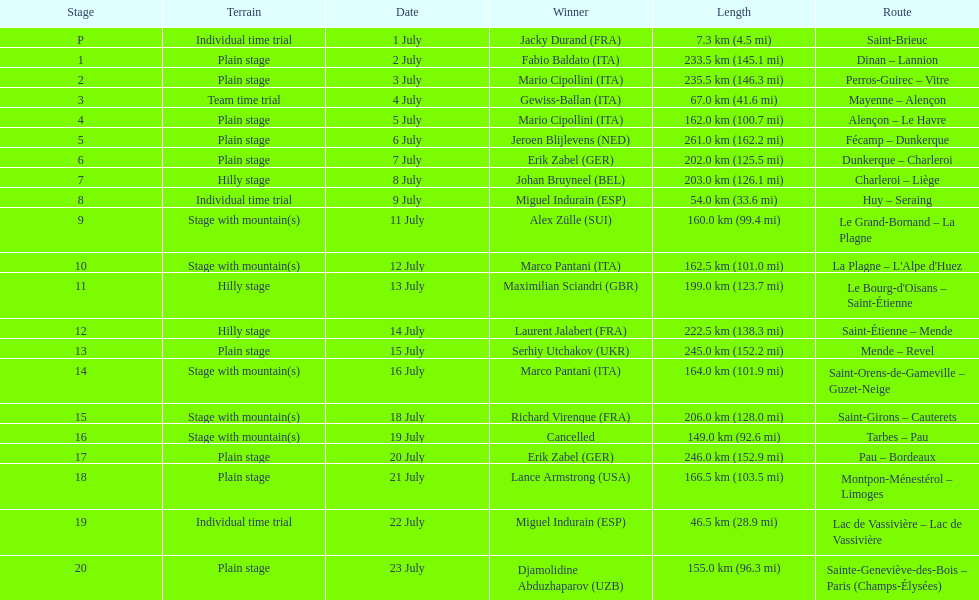After lance armstrong, who led next in the 1995 tour de france? Miguel Indurain. 